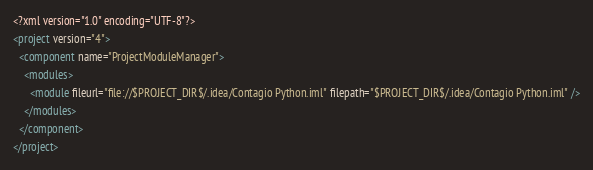<code> <loc_0><loc_0><loc_500><loc_500><_XML_><?xml version="1.0" encoding="UTF-8"?>
<project version="4">
  <component name="ProjectModuleManager">
    <modules>
      <module fileurl="file://$PROJECT_DIR$/.idea/Contagio Python.iml" filepath="$PROJECT_DIR$/.idea/Contagio Python.iml" />
    </modules>
  </component>
</project></code> 